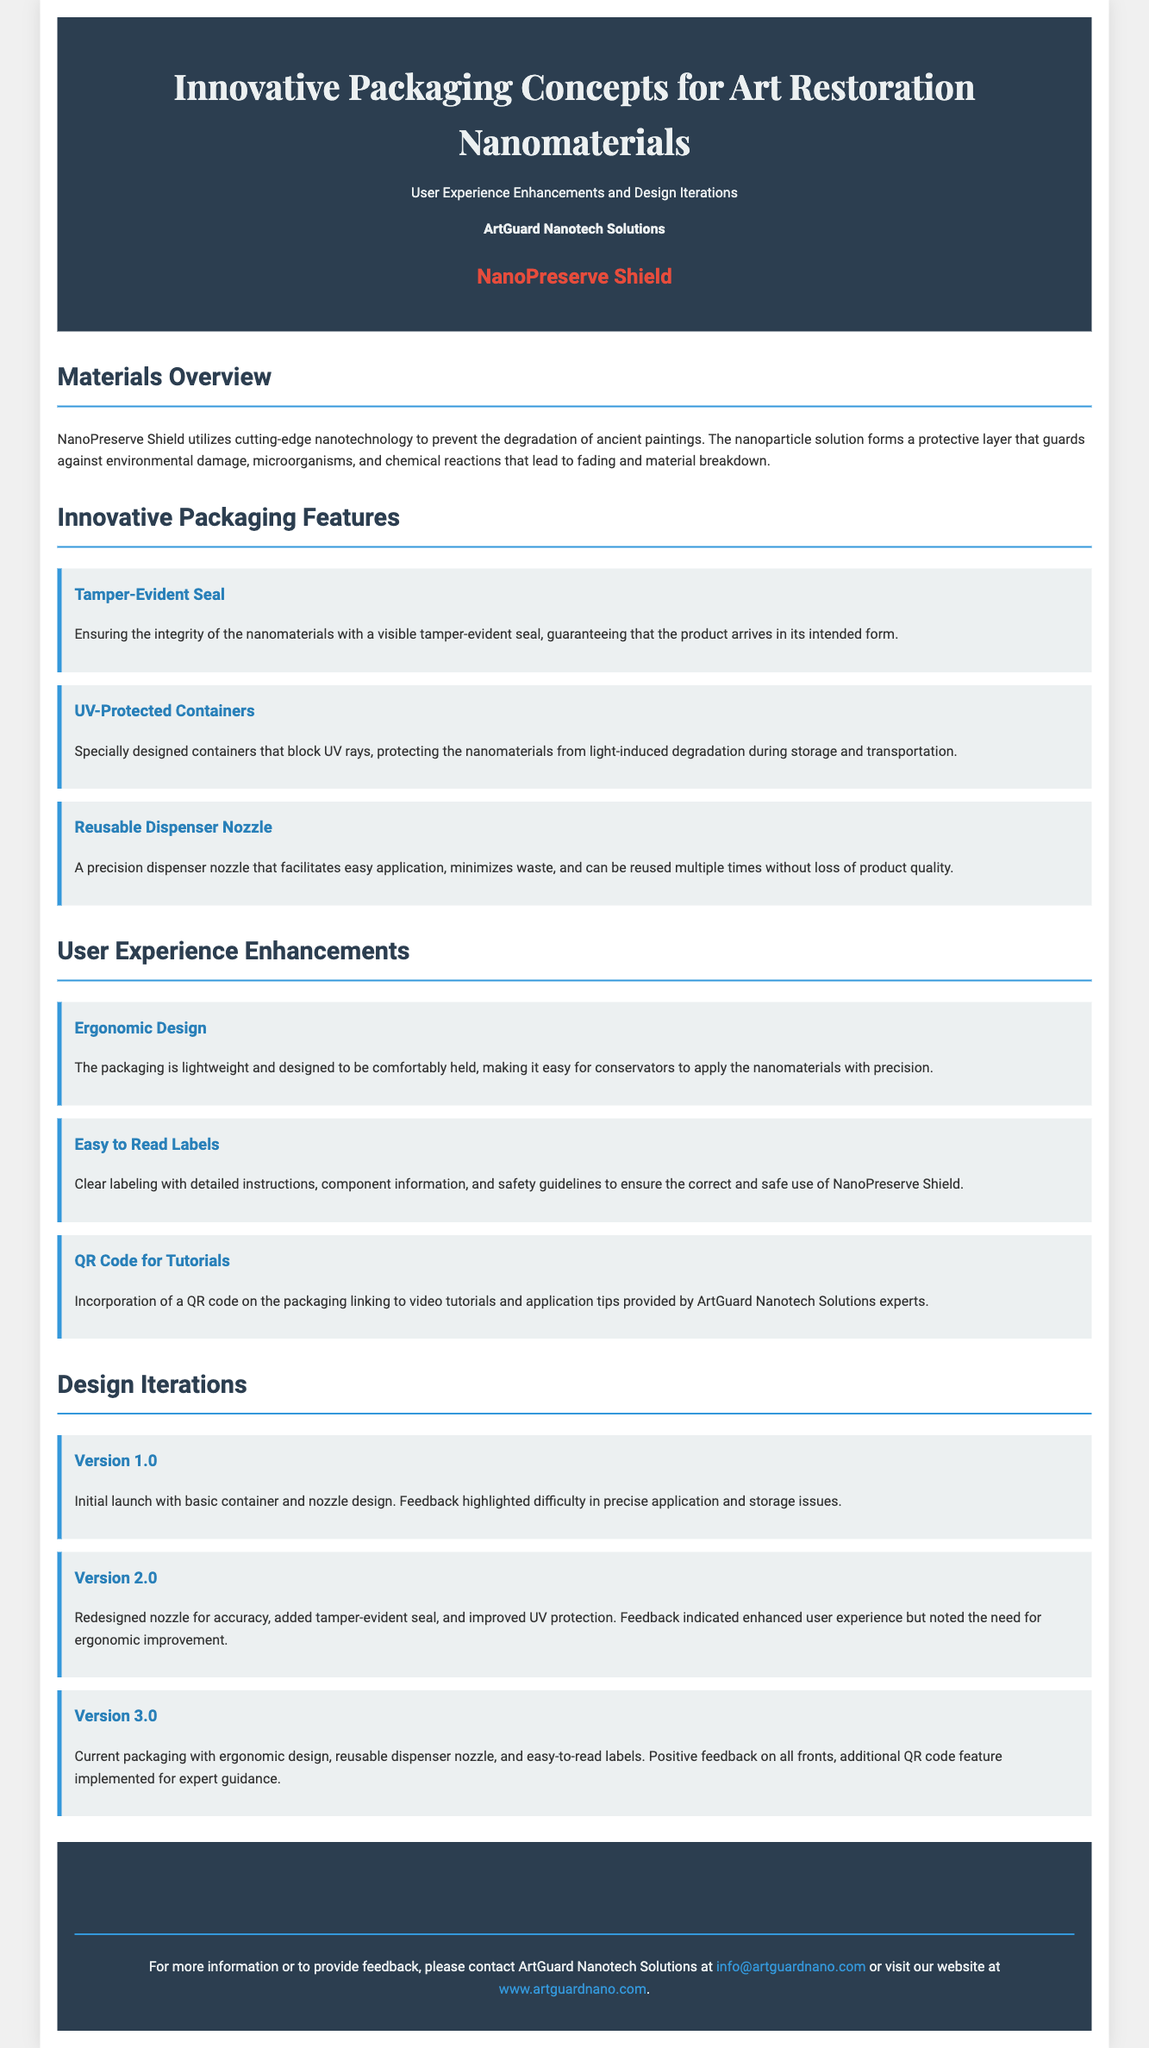What is the product name? The product name is highlighted in the document under the header, prominently stated as "NanoPreserve Shield."
Answer: NanoPreserve Shield Who is the manufacturer of the product? The manufacturer is mentioned in the header as "ArtGuard Nanotech Solutions."
Answer: ArtGuard Nanotech Solutions What feature ensures product integrity during transport? The tamper-evident seal is specifically mentioned as a feature that guarantees product integrity.
Answer: Tamper-Evident Seal What is the focus of NanoPreserve Shield technology? The main aim of the technology is to prevent degradation caused by environmental factors, which is stated in the materials overview section.
Answer: Prevent degradation Which version introduced an ergonomic design? Version 3.0 is the current packaging iteration that includes ergonomic design improvements.
Answer: Version 3.0 What type of code is included for tutorials? The packaging includes a QR code that links to video tutorials for users.
Answer: QR Code How does the packaging protect against light damage? The document states that UV-protected containers help in blocking UV rays during storage and transportation.
Answer: UV-Protected Containers What improvement was made in Version 2.0? The redesigned nozzle for accuracy was one of the significant improvements made in Version 2.0.
Answer: Redesigned nozzle What information is clearly labeled on the packaging? The labels contain detailed instructions, component information, and safety guidelines for the product use.
Answer: Detailed instructions 